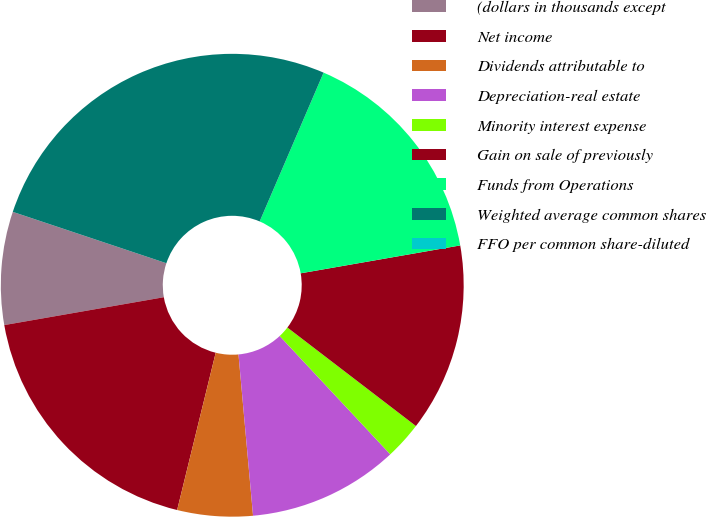Convert chart to OTSL. <chart><loc_0><loc_0><loc_500><loc_500><pie_chart><fcel>(dollars in thousands except<fcel>Net income<fcel>Dividends attributable to<fcel>Depreciation-real estate<fcel>Minority interest expense<fcel>Gain on sale of previously<fcel>Funds from Operations<fcel>Weighted average common shares<fcel>FFO per common share-diluted<nl><fcel>7.89%<fcel>18.42%<fcel>5.26%<fcel>10.53%<fcel>2.63%<fcel>13.16%<fcel>15.79%<fcel>26.32%<fcel>0.0%<nl></chart> 